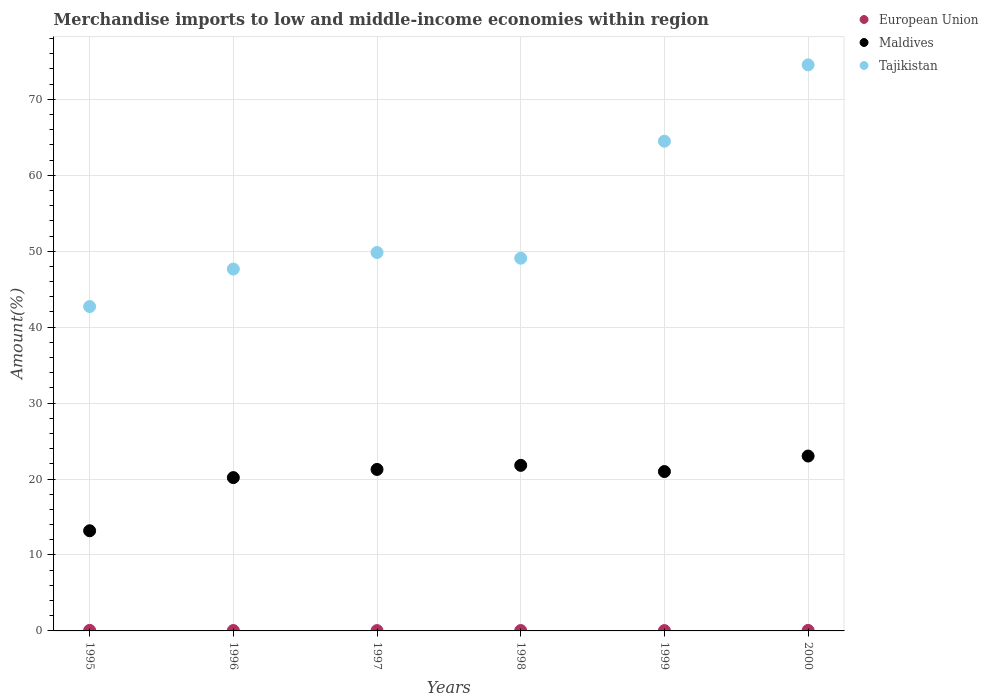Is the number of dotlines equal to the number of legend labels?
Make the answer very short. Yes. What is the percentage of amount earned from merchandise imports in Maldives in 1999?
Your response must be concise. 20.99. Across all years, what is the maximum percentage of amount earned from merchandise imports in Maldives?
Offer a terse response. 23.03. Across all years, what is the minimum percentage of amount earned from merchandise imports in Maldives?
Give a very brief answer. 13.19. In which year was the percentage of amount earned from merchandise imports in European Union maximum?
Ensure brevity in your answer.  1995. In which year was the percentage of amount earned from merchandise imports in Maldives minimum?
Your answer should be very brief. 1995. What is the total percentage of amount earned from merchandise imports in Maldives in the graph?
Make the answer very short. 120.46. What is the difference between the percentage of amount earned from merchandise imports in European Union in 1997 and that in 1999?
Make the answer very short. -0. What is the difference between the percentage of amount earned from merchandise imports in European Union in 1998 and the percentage of amount earned from merchandise imports in Maldives in 1996?
Your answer should be compact. -20.14. What is the average percentage of amount earned from merchandise imports in Maldives per year?
Ensure brevity in your answer.  20.08. In the year 1999, what is the difference between the percentage of amount earned from merchandise imports in European Union and percentage of amount earned from merchandise imports in Maldives?
Ensure brevity in your answer.  -20.94. What is the ratio of the percentage of amount earned from merchandise imports in Maldives in 1999 to that in 2000?
Ensure brevity in your answer.  0.91. Is the difference between the percentage of amount earned from merchandise imports in European Union in 1996 and 1997 greater than the difference between the percentage of amount earned from merchandise imports in Maldives in 1996 and 1997?
Your answer should be compact. Yes. What is the difference between the highest and the second highest percentage of amount earned from merchandise imports in European Union?
Your answer should be compact. 0.01. What is the difference between the highest and the lowest percentage of amount earned from merchandise imports in Tajikistan?
Keep it short and to the point. 31.83. Is the sum of the percentage of amount earned from merchandise imports in Maldives in 1996 and 1998 greater than the maximum percentage of amount earned from merchandise imports in Tajikistan across all years?
Keep it short and to the point. No. Is it the case that in every year, the sum of the percentage of amount earned from merchandise imports in Tajikistan and percentage of amount earned from merchandise imports in European Union  is greater than the percentage of amount earned from merchandise imports in Maldives?
Make the answer very short. Yes. Is the percentage of amount earned from merchandise imports in Tajikistan strictly less than the percentage of amount earned from merchandise imports in European Union over the years?
Give a very brief answer. No. How many dotlines are there?
Offer a terse response. 3. What is the difference between two consecutive major ticks on the Y-axis?
Offer a very short reply. 10. Are the values on the major ticks of Y-axis written in scientific E-notation?
Your answer should be very brief. No. How are the legend labels stacked?
Ensure brevity in your answer.  Vertical. What is the title of the graph?
Give a very brief answer. Merchandise imports to low and middle-income economies within region. What is the label or title of the X-axis?
Give a very brief answer. Years. What is the label or title of the Y-axis?
Offer a terse response. Amount(%). What is the Amount(%) in European Union in 1995?
Provide a succinct answer. 0.07. What is the Amount(%) of Maldives in 1995?
Your answer should be very brief. 13.19. What is the Amount(%) of Tajikistan in 1995?
Your answer should be compact. 42.71. What is the Amount(%) in European Union in 1996?
Make the answer very short. 0.05. What is the Amount(%) of Maldives in 1996?
Ensure brevity in your answer.  20.19. What is the Amount(%) of Tajikistan in 1996?
Provide a short and direct response. 47.65. What is the Amount(%) of European Union in 1997?
Your response must be concise. 0.04. What is the Amount(%) in Maldives in 1997?
Provide a succinct answer. 21.27. What is the Amount(%) in Tajikistan in 1997?
Offer a terse response. 49.83. What is the Amount(%) of European Union in 1998?
Ensure brevity in your answer.  0.05. What is the Amount(%) in Maldives in 1998?
Offer a very short reply. 21.8. What is the Amount(%) in Tajikistan in 1998?
Your answer should be compact. 49.08. What is the Amount(%) in European Union in 1999?
Offer a very short reply. 0.04. What is the Amount(%) in Maldives in 1999?
Offer a very short reply. 20.99. What is the Amount(%) in Tajikistan in 1999?
Provide a short and direct response. 64.49. What is the Amount(%) in European Union in 2000?
Ensure brevity in your answer.  0.07. What is the Amount(%) in Maldives in 2000?
Make the answer very short. 23.03. What is the Amount(%) of Tajikistan in 2000?
Your answer should be very brief. 74.54. Across all years, what is the maximum Amount(%) of European Union?
Ensure brevity in your answer.  0.07. Across all years, what is the maximum Amount(%) in Maldives?
Make the answer very short. 23.03. Across all years, what is the maximum Amount(%) of Tajikistan?
Your response must be concise. 74.54. Across all years, what is the minimum Amount(%) in European Union?
Provide a succinct answer. 0.04. Across all years, what is the minimum Amount(%) in Maldives?
Make the answer very short. 13.19. Across all years, what is the minimum Amount(%) of Tajikistan?
Your response must be concise. 42.71. What is the total Amount(%) in European Union in the graph?
Your response must be concise. 0.33. What is the total Amount(%) in Maldives in the graph?
Your answer should be compact. 120.46. What is the total Amount(%) of Tajikistan in the graph?
Your answer should be compact. 328.31. What is the difference between the Amount(%) in European Union in 1995 and that in 1996?
Your response must be concise. 0.02. What is the difference between the Amount(%) in Maldives in 1995 and that in 1996?
Your answer should be very brief. -7. What is the difference between the Amount(%) in Tajikistan in 1995 and that in 1996?
Give a very brief answer. -4.94. What is the difference between the Amount(%) in European Union in 1995 and that in 1997?
Your response must be concise. 0.03. What is the difference between the Amount(%) in Maldives in 1995 and that in 1997?
Keep it short and to the point. -8.08. What is the difference between the Amount(%) in Tajikistan in 1995 and that in 1997?
Offer a very short reply. -7.12. What is the difference between the Amount(%) in European Union in 1995 and that in 1998?
Ensure brevity in your answer.  0.02. What is the difference between the Amount(%) in Maldives in 1995 and that in 1998?
Provide a succinct answer. -8.61. What is the difference between the Amount(%) of Tajikistan in 1995 and that in 1998?
Give a very brief answer. -6.37. What is the difference between the Amount(%) in European Union in 1995 and that in 1999?
Keep it short and to the point. 0.03. What is the difference between the Amount(%) of Maldives in 1995 and that in 1999?
Provide a short and direct response. -7.8. What is the difference between the Amount(%) of Tajikistan in 1995 and that in 1999?
Your answer should be compact. -21.78. What is the difference between the Amount(%) of European Union in 1995 and that in 2000?
Your answer should be compact. 0.01. What is the difference between the Amount(%) in Maldives in 1995 and that in 2000?
Keep it short and to the point. -9.84. What is the difference between the Amount(%) of Tajikistan in 1995 and that in 2000?
Your answer should be compact. -31.83. What is the difference between the Amount(%) of European Union in 1996 and that in 1997?
Offer a terse response. 0.01. What is the difference between the Amount(%) in Maldives in 1996 and that in 1997?
Provide a short and direct response. -1.08. What is the difference between the Amount(%) in Tajikistan in 1996 and that in 1997?
Offer a terse response. -2.18. What is the difference between the Amount(%) in European Union in 1996 and that in 1998?
Provide a short and direct response. 0. What is the difference between the Amount(%) in Maldives in 1996 and that in 1998?
Provide a short and direct response. -1.61. What is the difference between the Amount(%) of Tajikistan in 1996 and that in 1998?
Make the answer very short. -1.43. What is the difference between the Amount(%) in European Union in 1996 and that in 1999?
Provide a short and direct response. 0.01. What is the difference between the Amount(%) of Maldives in 1996 and that in 1999?
Your response must be concise. -0.8. What is the difference between the Amount(%) in Tajikistan in 1996 and that in 1999?
Your answer should be very brief. -16.84. What is the difference between the Amount(%) in European Union in 1996 and that in 2000?
Your answer should be compact. -0.01. What is the difference between the Amount(%) in Maldives in 1996 and that in 2000?
Your response must be concise. -2.84. What is the difference between the Amount(%) of Tajikistan in 1996 and that in 2000?
Provide a short and direct response. -26.89. What is the difference between the Amount(%) of European Union in 1997 and that in 1998?
Keep it short and to the point. -0.01. What is the difference between the Amount(%) in Maldives in 1997 and that in 1998?
Your response must be concise. -0.54. What is the difference between the Amount(%) of Tajikistan in 1997 and that in 1998?
Offer a very short reply. 0.75. What is the difference between the Amount(%) in European Union in 1997 and that in 1999?
Give a very brief answer. -0. What is the difference between the Amount(%) of Maldives in 1997 and that in 1999?
Offer a very short reply. 0.28. What is the difference between the Amount(%) of Tajikistan in 1997 and that in 1999?
Keep it short and to the point. -14.66. What is the difference between the Amount(%) in European Union in 1997 and that in 2000?
Keep it short and to the point. -0.02. What is the difference between the Amount(%) in Maldives in 1997 and that in 2000?
Provide a short and direct response. -1.76. What is the difference between the Amount(%) of Tajikistan in 1997 and that in 2000?
Keep it short and to the point. -24.71. What is the difference between the Amount(%) of European Union in 1998 and that in 1999?
Your answer should be compact. 0.01. What is the difference between the Amount(%) in Maldives in 1998 and that in 1999?
Your response must be concise. 0.82. What is the difference between the Amount(%) of Tajikistan in 1998 and that in 1999?
Offer a terse response. -15.41. What is the difference between the Amount(%) of European Union in 1998 and that in 2000?
Your response must be concise. -0.02. What is the difference between the Amount(%) of Maldives in 1998 and that in 2000?
Offer a very short reply. -1.23. What is the difference between the Amount(%) in Tajikistan in 1998 and that in 2000?
Make the answer very short. -25.46. What is the difference between the Amount(%) of European Union in 1999 and that in 2000?
Your answer should be compact. -0.02. What is the difference between the Amount(%) of Maldives in 1999 and that in 2000?
Offer a terse response. -2.04. What is the difference between the Amount(%) of Tajikistan in 1999 and that in 2000?
Your answer should be compact. -10.05. What is the difference between the Amount(%) in European Union in 1995 and the Amount(%) in Maldives in 1996?
Offer a very short reply. -20.12. What is the difference between the Amount(%) in European Union in 1995 and the Amount(%) in Tajikistan in 1996?
Offer a very short reply. -47.58. What is the difference between the Amount(%) in Maldives in 1995 and the Amount(%) in Tajikistan in 1996?
Provide a succinct answer. -34.46. What is the difference between the Amount(%) in European Union in 1995 and the Amount(%) in Maldives in 1997?
Provide a short and direct response. -21.19. What is the difference between the Amount(%) of European Union in 1995 and the Amount(%) of Tajikistan in 1997?
Offer a very short reply. -49.76. What is the difference between the Amount(%) in Maldives in 1995 and the Amount(%) in Tajikistan in 1997?
Make the answer very short. -36.64. What is the difference between the Amount(%) of European Union in 1995 and the Amount(%) of Maldives in 1998?
Your response must be concise. -21.73. What is the difference between the Amount(%) in European Union in 1995 and the Amount(%) in Tajikistan in 1998?
Provide a short and direct response. -49.01. What is the difference between the Amount(%) of Maldives in 1995 and the Amount(%) of Tajikistan in 1998?
Give a very brief answer. -35.89. What is the difference between the Amount(%) in European Union in 1995 and the Amount(%) in Maldives in 1999?
Give a very brief answer. -20.91. What is the difference between the Amount(%) of European Union in 1995 and the Amount(%) of Tajikistan in 1999?
Offer a very short reply. -64.42. What is the difference between the Amount(%) of Maldives in 1995 and the Amount(%) of Tajikistan in 1999?
Provide a short and direct response. -51.3. What is the difference between the Amount(%) in European Union in 1995 and the Amount(%) in Maldives in 2000?
Your answer should be very brief. -22.96. What is the difference between the Amount(%) in European Union in 1995 and the Amount(%) in Tajikistan in 2000?
Offer a terse response. -74.47. What is the difference between the Amount(%) in Maldives in 1995 and the Amount(%) in Tajikistan in 2000?
Offer a terse response. -61.35. What is the difference between the Amount(%) in European Union in 1996 and the Amount(%) in Maldives in 1997?
Your response must be concise. -21.21. What is the difference between the Amount(%) in European Union in 1996 and the Amount(%) in Tajikistan in 1997?
Give a very brief answer. -49.78. What is the difference between the Amount(%) of Maldives in 1996 and the Amount(%) of Tajikistan in 1997?
Your answer should be compact. -29.64. What is the difference between the Amount(%) in European Union in 1996 and the Amount(%) in Maldives in 1998?
Your answer should be very brief. -21.75. What is the difference between the Amount(%) in European Union in 1996 and the Amount(%) in Tajikistan in 1998?
Your answer should be compact. -49.03. What is the difference between the Amount(%) of Maldives in 1996 and the Amount(%) of Tajikistan in 1998?
Provide a short and direct response. -28.89. What is the difference between the Amount(%) of European Union in 1996 and the Amount(%) of Maldives in 1999?
Your answer should be compact. -20.93. What is the difference between the Amount(%) of European Union in 1996 and the Amount(%) of Tajikistan in 1999?
Offer a terse response. -64.44. What is the difference between the Amount(%) in Maldives in 1996 and the Amount(%) in Tajikistan in 1999?
Make the answer very short. -44.3. What is the difference between the Amount(%) in European Union in 1996 and the Amount(%) in Maldives in 2000?
Provide a short and direct response. -22.98. What is the difference between the Amount(%) in European Union in 1996 and the Amount(%) in Tajikistan in 2000?
Keep it short and to the point. -74.49. What is the difference between the Amount(%) of Maldives in 1996 and the Amount(%) of Tajikistan in 2000?
Your answer should be very brief. -54.35. What is the difference between the Amount(%) of European Union in 1997 and the Amount(%) of Maldives in 1998?
Your response must be concise. -21.76. What is the difference between the Amount(%) in European Union in 1997 and the Amount(%) in Tajikistan in 1998?
Your answer should be very brief. -49.04. What is the difference between the Amount(%) of Maldives in 1997 and the Amount(%) of Tajikistan in 1998?
Ensure brevity in your answer.  -27.82. What is the difference between the Amount(%) in European Union in 1997 and the Amount(%) in Maldives in 1999?
Provide a short and direct response. -20.94. What is the difference between the Amount(%) in European Union in 1997 and the Amount(%) in Tajikistan in 1999?
Give a very brief answer. -64.45. What is the difference between the Amount(%) in Maldives in 1997 and the Amount(%) in Tajikistan in 1999?
Provide a succinct answer. -43.22. What is the difference between the Amount(%) of European Union in 1997 and the Amount(%) of Maldives in 2000?
Make the answer very short. -22.99. What is the difference between the Amount(%) in European Union in 1997 and the Amount(%) in Tajikistan in 2000?
Provide a short and direct response. -74.5. What is the difference between the Amount(%) in Maldives in 1997 and the Amount(%) in Tajikistan in 2000?
Give a very brief answer. -53.28. What is the difference between the Amount(%) of European Union in 1998 and the Amount(%) of Maldives in 1999?
Give a very brief answer. -20.94. What is the difference between the Amount(%) of European Union in 1998 and the Amount(%) of Tajikistan in 1999?
Your response must be concise. -64.44. What is the difference between the Amount(%) of Maldives in 1998 and the Amount(%) of Tajikistan in 1999?
Offer a very short reply. -42.69. What is the difference between the Amount(%) of European Union in 1998 and the Amount(%) of Maldives in 2000?
Give a very brief answer. -22.98. What is the difference between the Amount(%) in European Union in 1998 and the Amount(%) in Tajikistan in 2000?
Your answer should be very brief. -74.49. What is the difference between the Amount(%) of Maldives in 1998 and the Amount(%) of Tajikistan in 2000?
Give a very brief answer. -52.74. What is the difference between the Amount(%) of European Union in 1999 and the Amount(%) of Maldives in 2000?
Your response must be concise. -22.98. What is the difference between the Amount(%) of European Union in 1999 and the Amount(%) of Tajikistan in 2000?
Make the answer very short. -74.5. What is the difference between the Amount(%) of Maldives in 1999 and the Amount(%) of Tajikistan in 2000?
Give a very brief answer. -53.56. What is the average Amount(%) of European Union per year?
Offer a terse response. 0.05. What is the average Amount(%) of Maldives per year?
Give a very brief answer. 20.08. What is the average Amount(%) in Tajikistan per year?
Ensure brevity in your answer.  54.72. In the year 1995, what is the difference between the Amount(%) in European Union and Amount(%) in Maldives?
Ensure brevity in your answer.  -13.12. In the year 1995, what is the difference between the Amount(%) of European Union and Amount(%) of Tajikistan?
Keep it short and to the point. -42.64. In the year 1995, what is the difference between the Amount(%) in Maldives and Amount(%) in Tajikistan?
Provide a short and direct response. -29.52. In the year 1996, what is the difference between the Amount(%) of European Union and Amount(%) of Maldives?
Offer a very short reply. -20.14. In the year 1996, what is the difference between the Amount(%) of European Union and Amount(%) of Tajikistan?
Provide a succinct answer. -47.6. In the year 1996, what is the difference between the Amount(%) of Maldives and Amount(%) of Tajikistan?
Your answer should be very brief. -27.46. In the year 1997, what is the difference between the Amount(%) of European Union and Amount(%) of Maldives?
Provide a short and direct response. -21.22. In the year 1997, what is the difference between the Amount(%) of European Union and Amount(%) of Tajikistan?
Your answer should be very brief. -49.79. In the year 1997, what is the difference between the Amount(%) in Maldives and Amount(%) in Tajikistan?
Your answer should be very brief. -28.56. In the year 1998, what is the difference between the Amount(%) in European Union and Amount(%) in Maldives?
Your answer should be compact. -21.75. In the year 1998, what is the difference between the Amount(%) of European Union and Amount(%) of Tajikistan?
Give a very brief answer. -49.03. In the year 1998, what is the difference between the Amount(%) in Maldives and Amount(%) in Tajikistan?
Provide a short and direct response. -27.28. In the year 1999, what is the difference between the Amount(%) in European Union and Amount(%) in Maldives?
Your answer should be very brief. -20.94. In the year 1999, what is the difference between the Amount(%) of European Union and Amount(%) of Tajikistan?
Offer a very short reply. -64.45. In the year 1999, what is the difference between the Amount(%) of Maldives and Amount(%) of Tajikistan?
Give a very brief answer. -43.5. In the year 2000, what is the difference between the Amount(%) of European Union and Amount(%) of Maldives?
Provide a short and direct response. -22.96. In the year 2000, what is the difference between the Amount(%) of European Union and Amount(%) of Tajikistan?
Ensure brevity in your answer.  -74.47. In the year 2000, what is the difference between the Amount(%) in Maldives and Amount(%) in Tajikistan?
Ensure brevity in your answer.  -51.51. What is the ratio of the Amount(%) of European Union in 1995 to that in 1996?
Keep it short and to the point. 1.38. What is the ratio of the Amount(%) in Maldives in 1995 to that in 1996?
Make the answer very short. 0.65. What is the ratio of the Amount(%) in Tajikistan in 1995 to that in 1996?
Your answer should be very brief. 0.9. What is the ratio of the Amount(%) of European Union in 1995 to that in 1997?
Provide a succinct answer. 1.66. What is the ratio of the Amount(%) of Maldives in 1995 to that in 1997?
Offer a terse response. 0.62. What is the ratio of the Amount(%) of Tajikistan in 1995 to that in 1997?
Offer a terse response. 0.86. What is the ratio of the Amount(%) of European Union in 1995 to that in 1998?
Ensure brevity in your answer.  1.45. What is the ratio of the Amount(%) of Maldives in 1995 to that in 1998?
Ensure brevity in your answer.  0.6. What is the ratio of the Amount(%) of Tajikistan in 1995 to that in 1998?
Ensure brevity in your answer.  0.87. What is the ratio of the Amount(%) of European Union in 1995 to that in 1999?
Your answer should be very brief. 1.63. What is the ratio of the Amount(%) in Maldives in 1995 to that in 1999?
Offer a very short reply. 0.63. What is the ratio of the Amount(%) of Tajikistan in 1995 to that in 1999?
Your answer should be very brief. 0.66. What is the ratio of the Amount(%) of European Union in 1995 to that in 2000?
Your response must be concise. 1.09. What is the ratio of the Amount(%) of Maldives in 1995 to that in 2000?
Make the answer very short. 0.57. What is the ratio of the Amount(%) in Tajikistan in 1995 to that in 2000?
Your answer should be very brief. 0.57. What is the ratio of the Amount(%) in European Union in 1996 to that in 1997?
Keep it short and to the point. 1.2. What is the ratio of the Amount(%) of Maldives in 1996 to that in 1997?
Your answer should be very brief. 0.95. What is the ratio of the Amount(%) in Tajikistan in 1996 to that in 1997?
Provide a short and direct response. 0.96. What is the ratio of the Amount(%) in European Union in 1996 to that in 1998?
Your answer should be compact. 1.05. What is the ratio of the Amount(%) of Maldives in 1996 to that in 1998?
Offer a very short reply. 0.93. What is the ratio of the Amount(%) in Tajikistan in 1996 to that in 1998?
Your answer should be compact. 0.97. What is the ratio of the Amount(%) of European Union in 1996 to that in 1999?
Offer a terse response. 1.18. What is the ratio of the Amount(%) of Maldives in 1996 to that in 1999?
Your answer should be compact. 0.96. What is the ratio of the Amount(%) of Tajikistan in 1996 to that in 1999?
Offer a terse response. 0.74. What is the ratio of the Amount(%) in European Union in 1996 to that in 2000?
Your answer should be very brief. 0.78. What is the ratio of the Amount(%) in Maldives in 1996 to that in 2000?
Your response must be concise. 0.88. What is the ratio of the Amount(%) of Tajikistan in 1996 to that in 2000?
Your response must be concise. 0.64. What is the ratio of the Amount(%) of European Union in 1997 to that in 1998?
Keep it short and to the point. 0.87. What is the ratio of the Amount(%) of Maldives in 1997 to that in 1998?
Provide a short and direct response. 0.98. What is the ratio of the Amount(%) in Tajikistan in 1997 to that in 1998?
Ensure brevity in your answer.  1.02. What is the ratio of the Amount(%) in European Union in 1997 to that in 1999?
Your answer should be compact. 0.99. What is the ratio of the Amount(%) of Maldives in 1997 to that in 1999?
Provide a succinct answer. 1.01. What is the ratio of the Amount(%) in Tajikistan in 1997 to that in 1999?
Offer a terse response. 0.77. What is the ratio of the Amount(%) in European Union in 1997 to that in 2000?
Provide a short and direct response. 0.66. What is the ratio of the Amount(%) in Maldives in 1997 to that in 2000?
Provide a succinct answer. 0.92. What is the ratio of the Amount(%) in Tajikistan in 1997 to that in 2000?
Offer a very short reply. 0.67. What is the ratio of the Amount(%) in European Union in 1998 to that in 1999?
Ensure brevity in your answer.  1.13. What is the ratio of the Amount(%) in Maldives in 1998 to that in 1999?
Provide a succinct answer. 1.04. What is the ratio of the Amount(%) in Tajikistan in 1998 to that in 1999?
Ensure brevity in your answer.  0.76. What is the ratio of the Amount(%) of European Union in 1998 to that in 2000?
Keep it short and to the point. 0.75. What is the ratio of the Amount(%) in Maldives in 1998 to that in 2000?
Make the answer very short. 0.95. What is the ratio of the Amount(%) in Tajikistan in 1998 to that in 2000?
Make the answer very short. 0.66. What is the ratio of the Amount(%) of European Union in 1999 to that in 2000?
Give a very brief answer. 0.66. What is the ratio of the Amount(%) of Maldives in 1999 to that in 2000?
Your answer should be very brief. 0.91. What is the ratio of the Amount(%) of Tajikistan in 1999 to that in 2000?
Your answer should be very brief. 0.87. What is the difference between the highest and the second highest Amount(%) of European Union?
Provide a short and direct response. 0.01. What is the difference between the highest and the second highest Amount(%) in Maldives?
Keep it short and to the point. 1.23. What is the difference between the highest and the second highest Amount(%) of Tajikistan?
Provide a short and direct response. 10.05. What is the difference between the highest and the lowest Amount(%) in European Union?
Give a very brief answer. 0.03. What is the difference between the highest and the lowest Amount(%) of Maldives?
Offer a terse response. 9.84. What is the difference between the highest and the lowest Amount(%) in Tajikistan?
Keep it short and to the point. 31.83. 